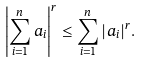Convert formula to latex. <formula><loc_0><loc_0><loc_500><loc_500>\left | \sum _ { i = 1 } ^ { n } a _ { i } \right | ^ { r } \leq \sum _ { i = 1 } ^ { n } | a _ { i } | ^ { r } .</formula> 